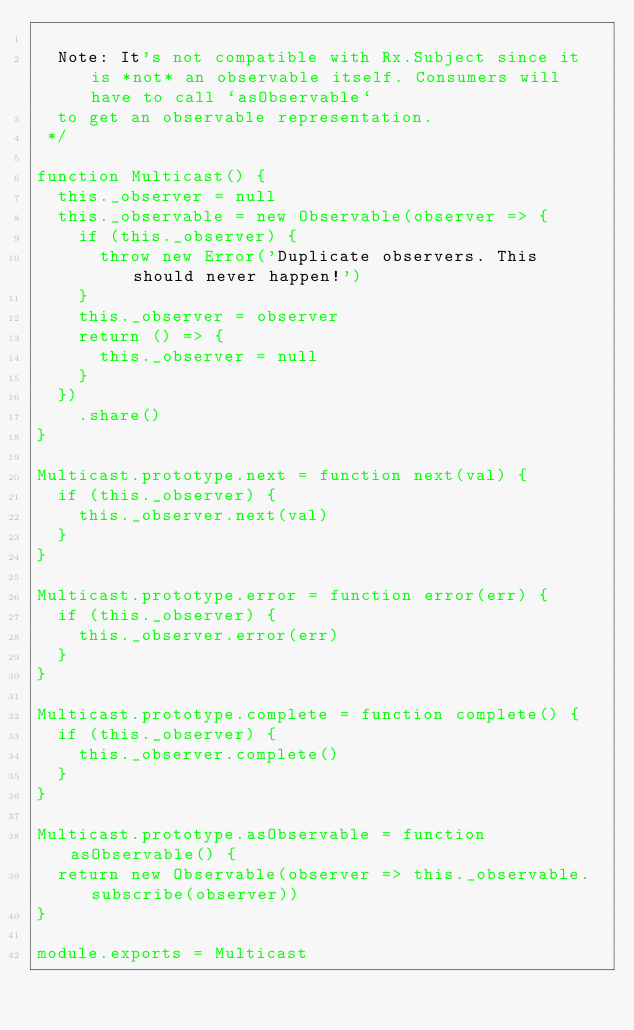Convert code to text. <code><loc_0><loc_0><loc_500><loc_500><_JavaScript_>
  Note: It's not compatible with Rx.Subject since it is *not* an observable itself. Consumers will have to call `asObservable`
  to get an observable representation.
 */

function Multicast() {
  this._observer = null
  this._observable = new Observable(observer => {
    if (this._observer) {
      throw new Error('Duplicate observers. This should never happen!')
    }
    this._observer = observer
    return () => {
      this._observer = null
    }
  })
    .share()
}

Multicast.prototype.next = function next(val) {
  if (this._observer) {
    this._observer.next(val)
  }
}

Multicast.prototype.error = function error(err) {
  if (this._observer) {
    this._observer.error(err)
  }
}

Multicast.prototype.complete = function complete() {
  if (this._observer) {
    this._observer.complete()
  }
}

Multicast.prototype.asObservable = function asObservable() {
  return new Observable(observer => this._observable.subscribe(observer))
}

module.exports = Multicast
</code> 